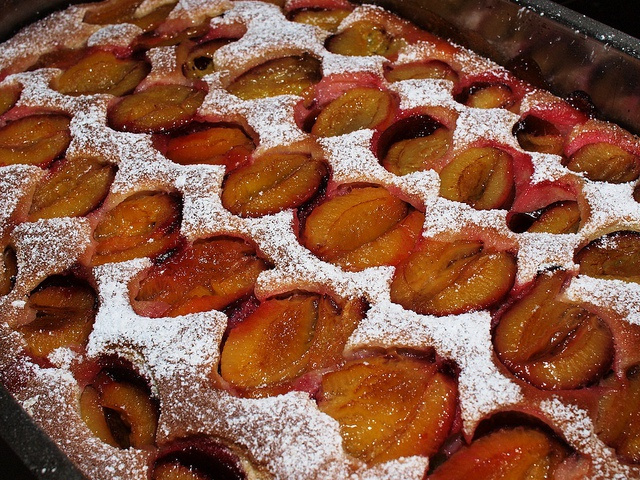Describe the objects in this image and their specific colors. I can see cake in maroon, brown, lightgray, and black tones, donut in black, brown, and maroon tones, donut in black, brown, and maroon tones, donut in black, brown, and maroon tones, and donut in black, brown, and maroon tones in this image. 